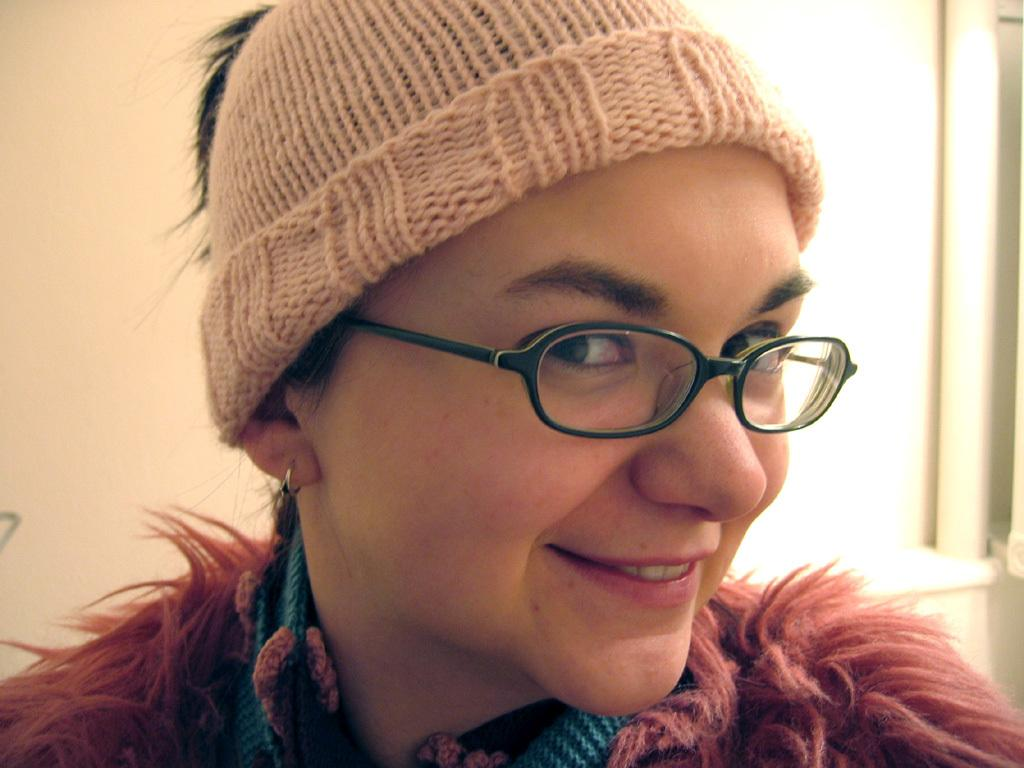Who or what is the main subject in the image? There is a person in the image. What is the person standing in front of? The person is in front of a wall. What accessories is the person wearing? The person is wearing a cap and spectacles. How many cats are sitting on the person's lap in the image? There are no cats present in the image. What is the temperature like in the image? The provided facts do not give any information about the temperature or heat in the image. 